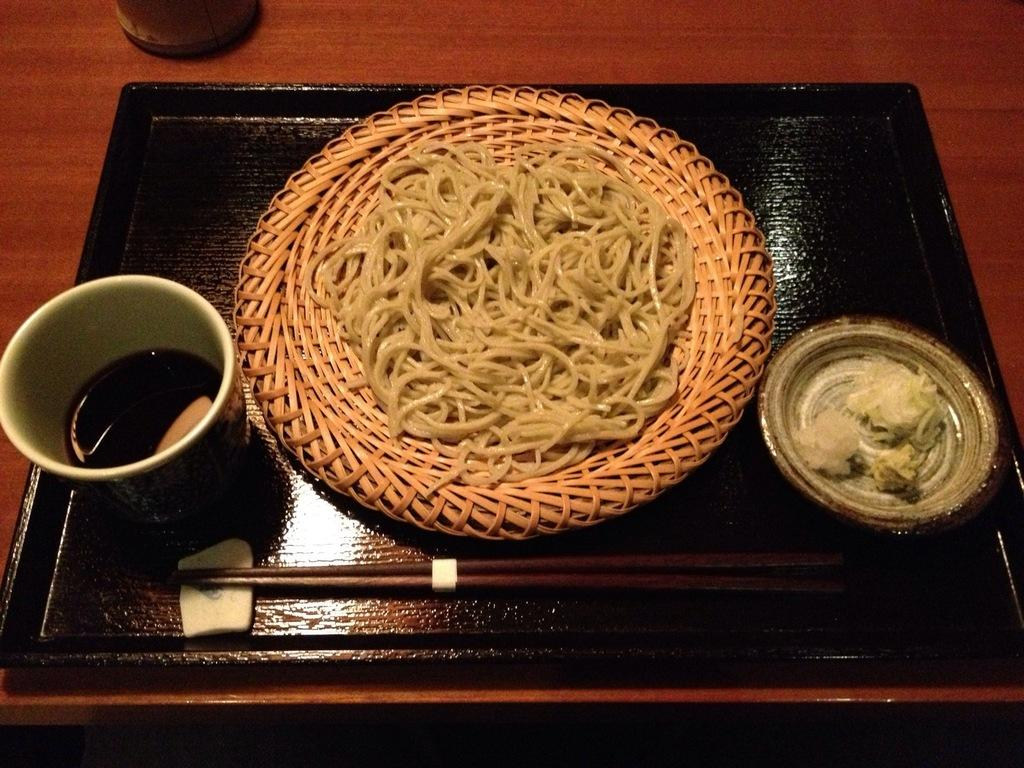What is the main object on the tray in the image? There are food items on the tray in the image. What utensils are present on the tray? Chopsticks are present on the tray. On what surface is the tray placed? The tray is placed on a wooden table. Can you see any toes on the wooden table in the image? There are no toes visible in the image; it features a tray with food items and chopsticks on a wooden table. 